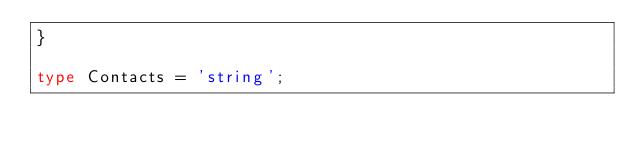<code> <loc_0><loc_0><loc_500><loc_500><_TypeScript_>}

type Contacts = 'string';

</code> 